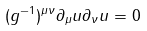Convert formula to latex. <formula><loc_0><loc_0><loc_500><loc_500>( g ^ { - 1 } ) ^ { \mu \nu } \partial _ { \mu } u \partial _ { \nu } u = 0</formula> 